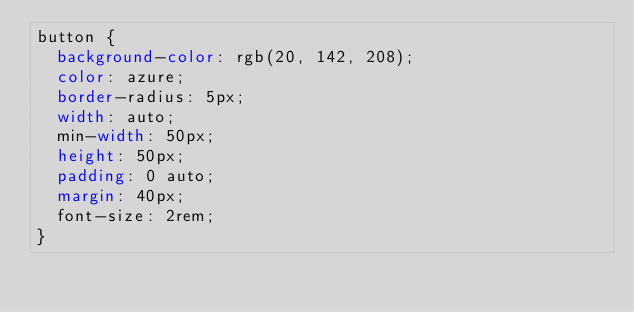Convert code to text. <code><loc_0><loc_0><loc_500><loc_500><_CSS_>button {
  background-color: rgb(20, 142, 208);
  color: azure;
  border-radius: 5px;
  width: auto;
  min-width: 50px;
  height: 50px;
  padding: 0 auto;
  margin: 40px;
  font-size: 2rem;
}</code> 